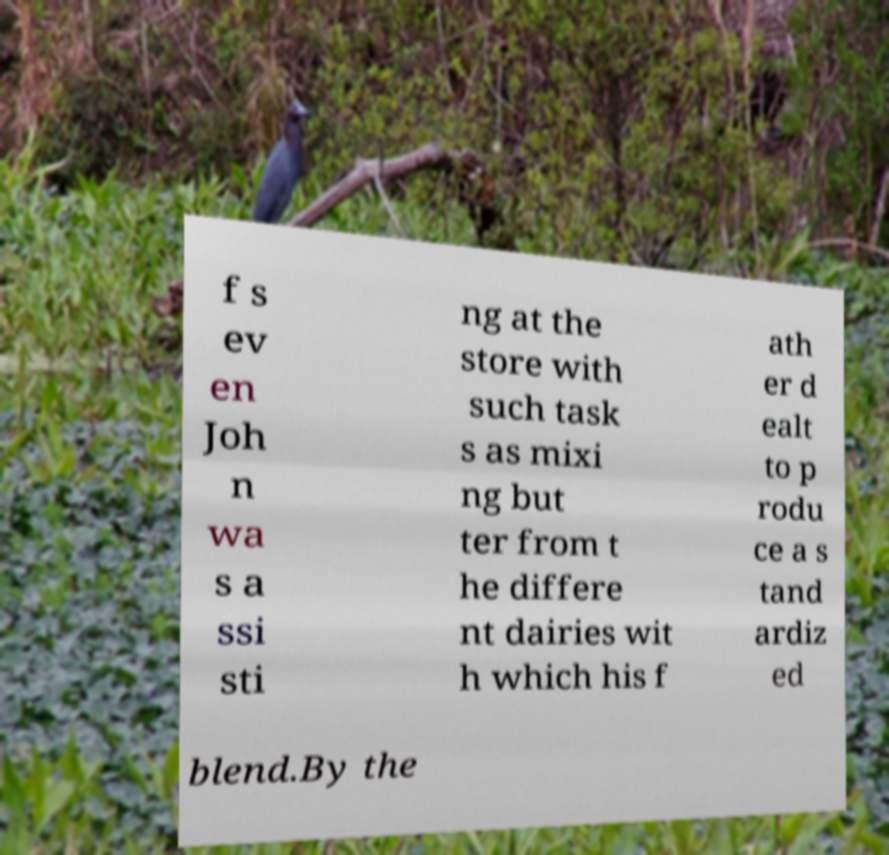Could you assist in decoding the text presented in this image and type it out clearly? f s ev en Joh n wa s a ssi sti ng at the store with such task s as mixi ng but ter from t he differe nt dairies wit h which his f ath er d ealt to p rodu ce a s tand ardiz ed blend.By the 